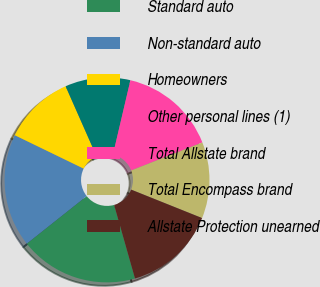Convert chart. <chart><loc_0><loc_0><loc_500><loc_500><pie_chart><fcel>Standard auto<fcel>Non-standard auto<fcel>Homeowners<fcel>Other personal lines (1)<fcel>Total Allstate brand<fcel>Total Encompass brand<fcel>Allstate Protection unearned<nl><fcel>18.72%<fcel>17.87%<fcel>11.19%<fcel>10.29%<fcel>15.37%<fcel>12.03%<fcel>14.53%<nl></chart> 